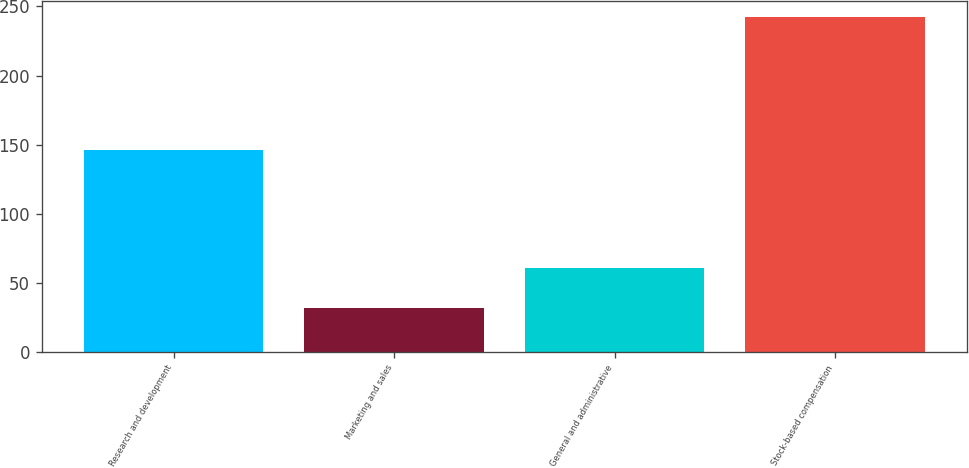Convert chart to OTSL. <chart><loc_0><loc_0><loc_500><loc_500><bar_chart><fcel>Research and development<fcel>Marketing and sales<fcel>General and administrative<fcel>Stock-based compensation<nl><fcel>146<fcel>32<fcel>61<fcel>242<nl></chart> 